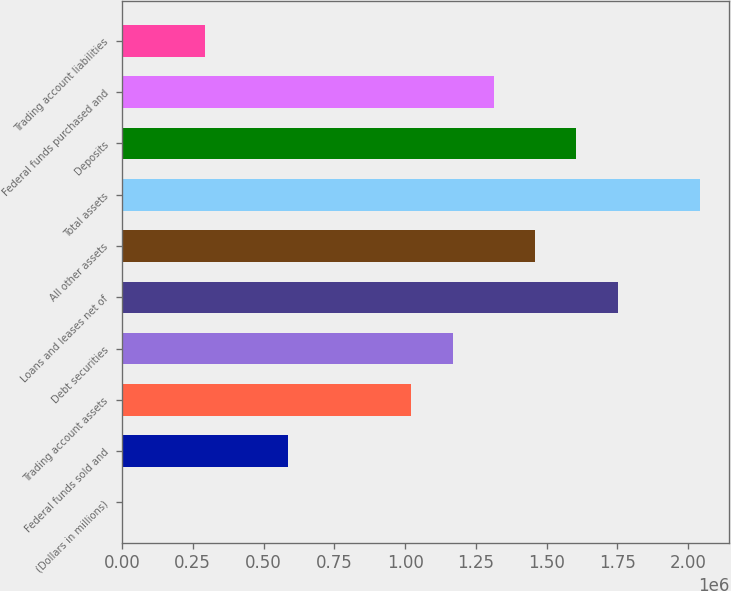<chart> <loc_0><loc_0><loc_500><loc_500><bar_chart><fcel>(Dollars in millions)<fcel>Federal funds sold and<fcel>Trading account assets<fcel>Debt securities<fcel>Loans and leases net of<fcel>All other assets<fcel>Total assets<fcel>Deposits<fcel>Federal funds purchased and<fcel>Trading account liabilities<nl><fcel>2006<fcel>585098<fcel>1.02242e+06<fcel>1.16819e+06<fcel>1.75128e+06<fcel>1.45974e+06<fcel>2.04283e+06<fcel>1.60551e+06<fcel>1.31396e+06<fcel>293552<nl></chart> 